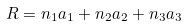Convert formula to latex. <formula><loc_0><loc_0><loc_500><loc_500>R = n _ { 1 } a _ { 1 } + n _ { 2 } a _ { 2 } + n _ { 3 } a _ { 3 }</formula> 